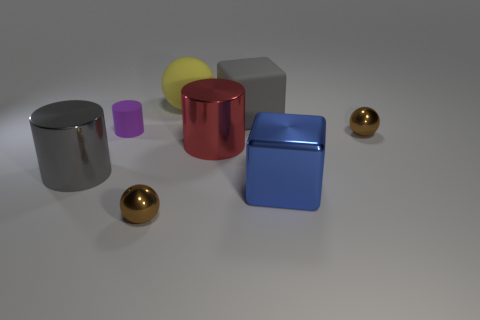Can you describe the texture and overall aesthetic of the objects in the scene? The objects display a smooth, almost reflective surface texture, giving them a polished metallic look. The scene's aesthetic is minimalist and modern, with each object bathed in soft, even lighting, highlighting their simple geometric forms. 